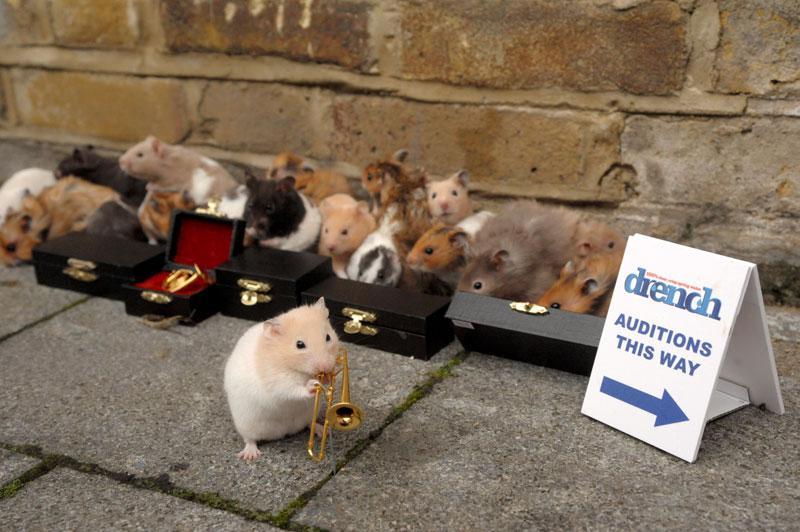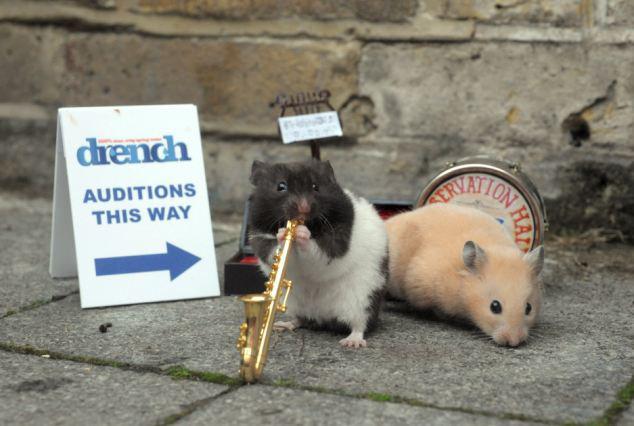The first image is the image on the left, the second image is the image on the right. Considering the images on both sides, is "THere are at least two hamsters in the image on the right." valid? Answer yes or no. Yes. The first image is the image on the left, the second image is the image on the right. For the images shown, is this caption "At least one of the animals is interacting with something." true? Answer yes or no. Yes. 